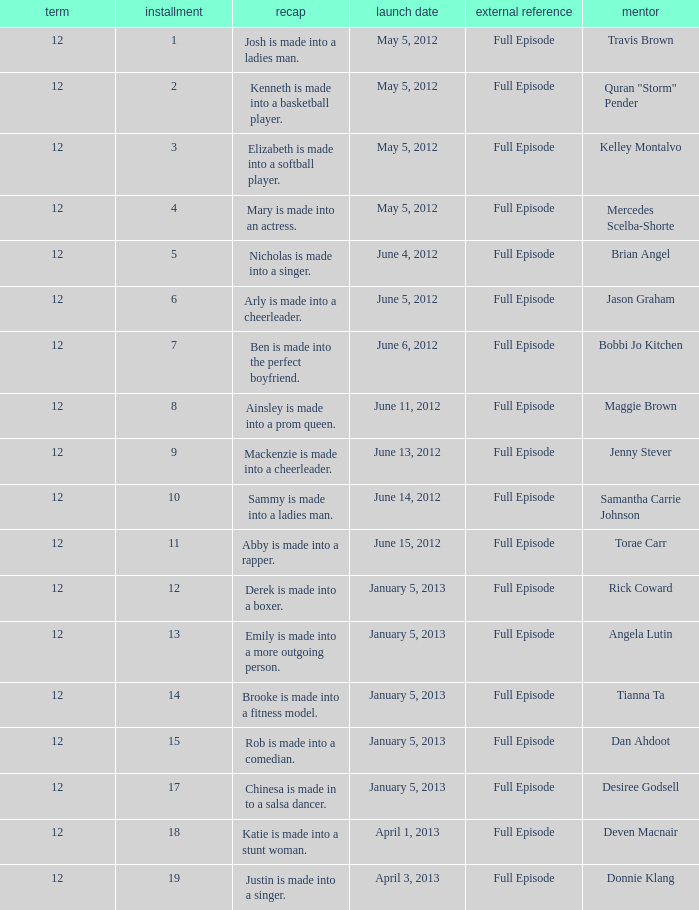Name the least episode for donnie klang 19.0. Can you parse all the data within this table? {'header': ['term', 'installment', 'recap', 'launch date', 'external reference', 'mentor'], 'rows': [['12', '1', 'Josh is made into a ladies man.', 'May 5, 2012', 'Full Episode', 'Travis Brown'], ['12', '2', 'Kenneth is made into a basketball player.', 'May 5, 2012', 'Full Episode', 'Quran "Storm" Pender'], ['12', '3', 'Elizabeth is made into a softball player.', 'May 5, 2012', 'Full Episode', 'Kelley Montalvo'], ['12', '4', 'Mary is made into an actress.', 'May 5, 2012', 'Full Episode', 'Mercedes Scelba-Shorte'], ['12', '5', 'Nicholas is made into a singer.', 'June 4, 2012', 'Full Episode', 'Brian Angel'], ['12', '6', 'Arly is made into a cheerleader.', 'June 5, 2012', 'Full Episode', 'Jason Graham'], ['12', '7', 'Ben is made into the perfect boyfriend.', 'June 6, 2012', 'Full Episode', 'Bobbi Jo Kitchen'], ['12', '8', 'Ainsley is made into a prom queen.', 'June 11, 2012', 'Full Episode', 'Maggie Brown'], ['12', '9', 'Mackenzie is made into a cheerleader.', 'June 13, 2012', 'Full Episode', 'Jenny Stever'], ['12', '10', 'Sammy is made into a ladies man.', 'June 14, 2012', 'Full Episode', 'Samantha Carrie Johnson'], ['12', '11', 'Abby is made into a rapper.', 'June 15, 2012', 'Full Episode', 'Torae Carr'], ['12', '12', 'Derek is made into a boxer.', 'January 5, 2013', 'Full Episode', 'Rick Coward'], ['12', '13', 'Emily is made into a more outgoing person.', 'January 5, 2013', 'Full Episode', 'Angela Lutin'], ['12', '14', 'Brooke is made into a fitness model.', 'January 5, 2013', 'Full Episode', 'Tianna Ta'], ['12', '15', 'Rob is made into a comedian.', 'January 5, 2013', 'Full Episode', 'Dan Ahdoot'], ['12', '17', 'Chinesa is made in to a salsa dancer.', 'January 5, 2013', 'Full Episode', 'Desiree Godsell'], ['12', '18', 'Katie is made into a stunt woman.', 'April 1, 2013', 'Full Episode', 'Deven Macnair'], ['12', '19', 'Justin is made into a singer.', 'April 3, 2013', 'Full Episode', 'Donnie Klang']]} 